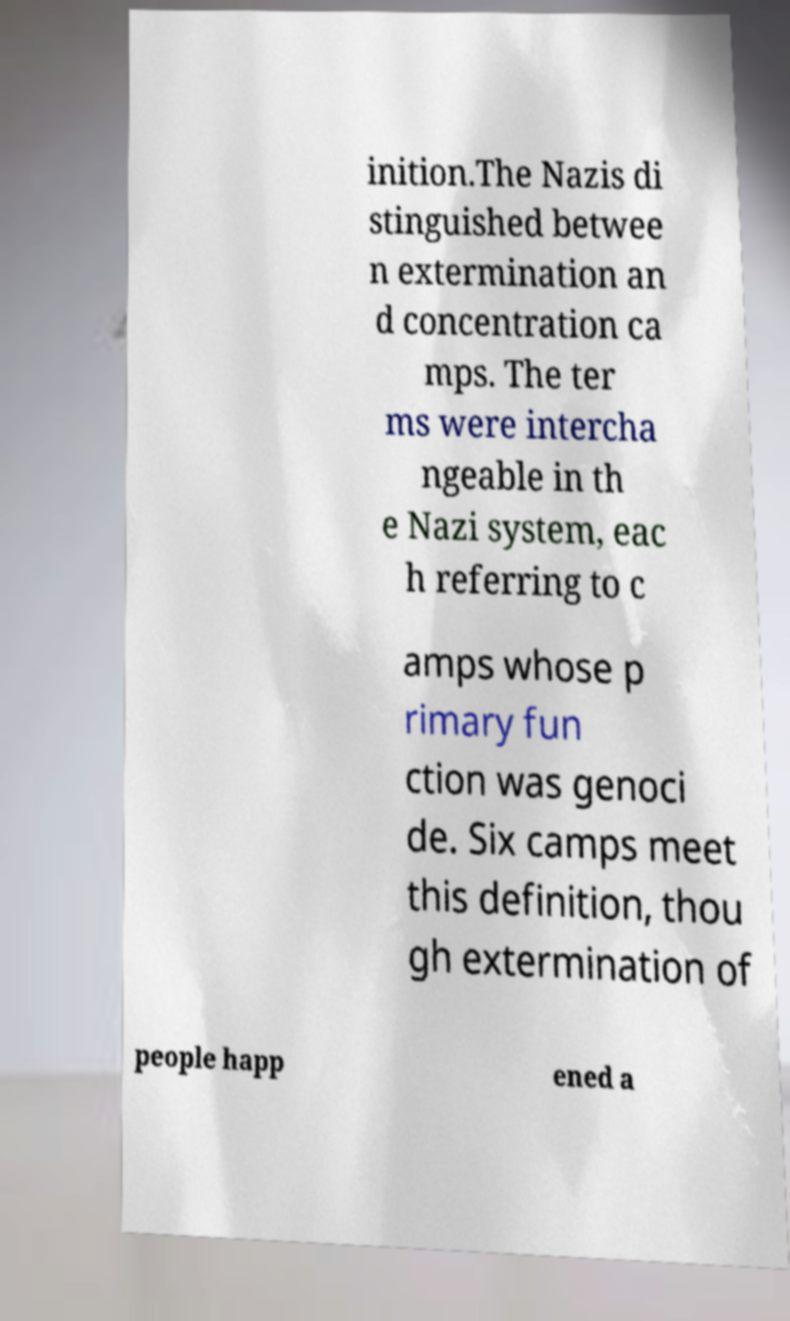For documentation purposes, I need the text within this image transcribed. Could you provide that? inition.The Nazis di stinguished betwee n extermination an d concentration ca mps. The ter ms were intercha ngeable in th e Nazi system, eac h referring to c amps whose p rimary fun ction was genoci de. Six camps meet this definition, thou gh extermination of people happ ened a 